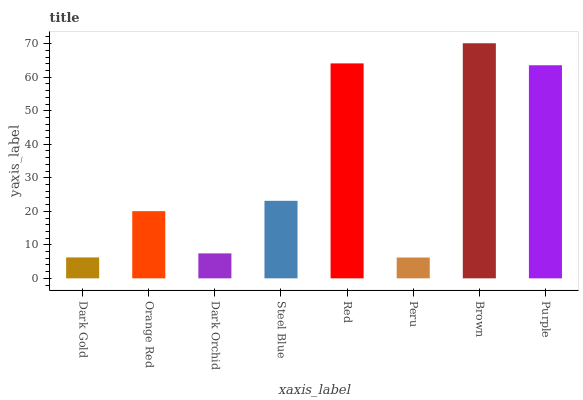Is Peru the minimum?
Answer yes or no. Yes. Is Brown the maximum?
Answer yes or no. Yes. Is Orange Red the minimum?
Answer yes or no. No. Is Orange Red the maximum?
Answer yes or no. No. Is Orange Red greater than Dark Gold?
Answer yes or no. Yes. Is Dark Gold less than Orange Red?
Answer yes or no. Yes. Is Dark Gold greater than Orange Red?
Answer yes or no. No. Is Orange Red less than Dark Gold?
Answer yes or no. No. Is Steel Blue the high median?
Answer yes or no. Yes. Is Orange Red the low median?
Answer yes or no. Yes. Is Dark Gold the high median?
Answer yes or no. No. Is Red the low median?
Answer yes or no. No. 